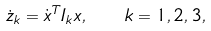Convert formula to latex. <formula><loc_0><loc_0><loc_500><loc_500>\dot { z } _ { k } = \dot { x } ^ { T } I _ { k } x , \quad k = 1 , 2 , 3 ,</formula> 